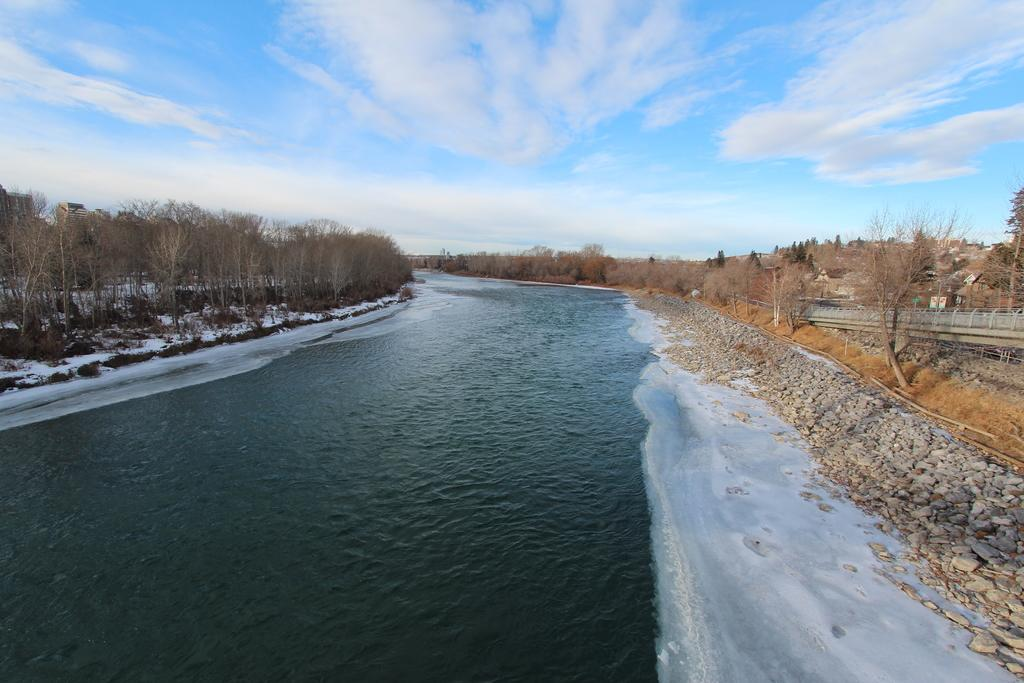What is the primary element in the image? There is water in the image. What can be seen in the center of the image? There are stones in the center of the image. What type of vegetation is present on both sides of the image? There are trees on both sides of the image. What is visible in the background of the image? The sky is visible in the background of the image. What type of quill is being used to write on the stones in the image? There is no quill or writing present in the image; it features water, stones, trees, and the sky. What sound can be heard coming from the trees in the image? There is no sound present in the image, as it is a still image and does not include any audio. 